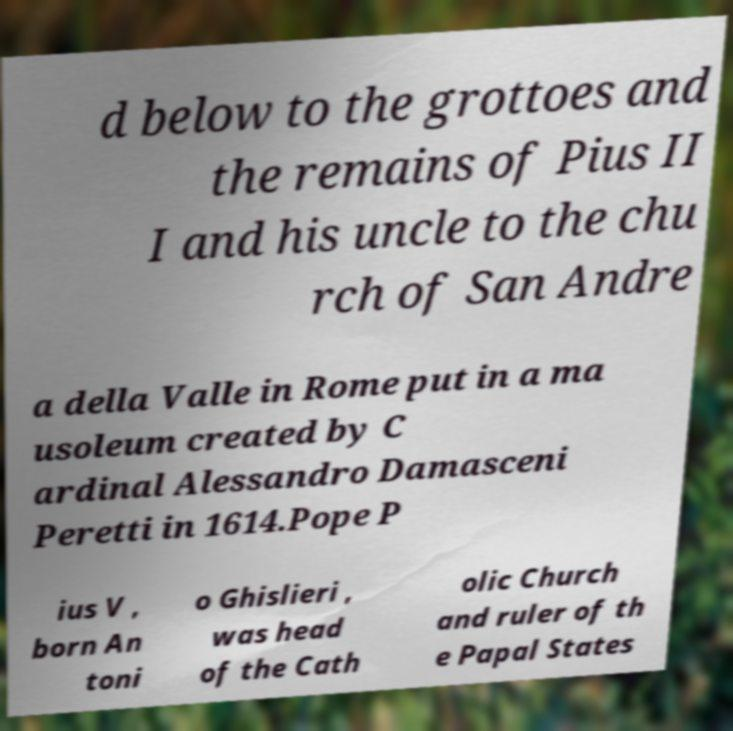Can you read and provide the text displayed in the image?This photo seems to have some interesting text. Can you extract and type it out for me? d below to the grottoes and the remains of Pius II I and his uncle to the chu rch of San Andre a della Valle in Rome put in a ma usoleum created by C ardinal Alessandro Damasceni Peretti in 1614.Pope P ius V , born An toni o Ghislieri , was head of the Cath olic Church and ruler of th e Papal States 